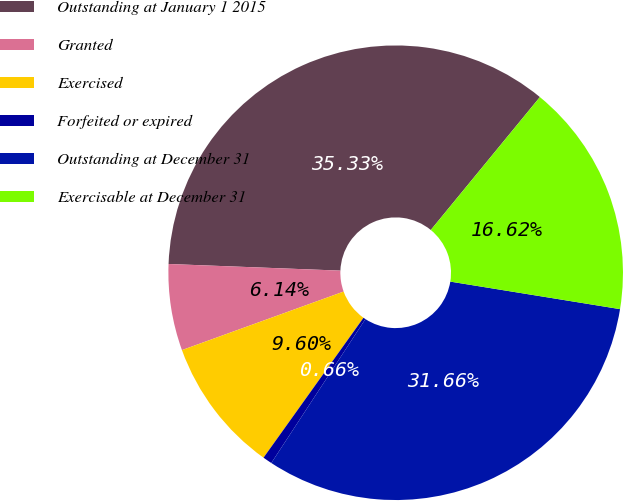Convert chart to OTSL. <chart><loc_0><loc_0><loc_500><loc_500><pie_chart><fcel>Outstanding at January 1 2015<fcel>Granted<fcel>Exercised<fcel>Forfeited or expired<fcel>Outstanding at December 31<fcel>Exercisable at December 31<nl><fcel>35.33%<fcel>6.14%<fcel>9.6%<fcel>0.66%<fcel>31.66%<fcel>16.62%<nl></chart> 